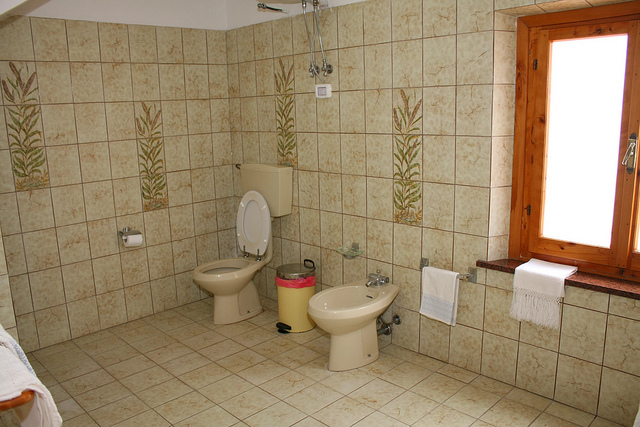<image>Who cleaned this room? It is unanswerable who cleaned the room. It could be a maid, a housekeeper, or even a mom. Who cleaned this room? I am not sure who cleaned this room. It can be either the maid, mom, housekeeper, or janitor. 